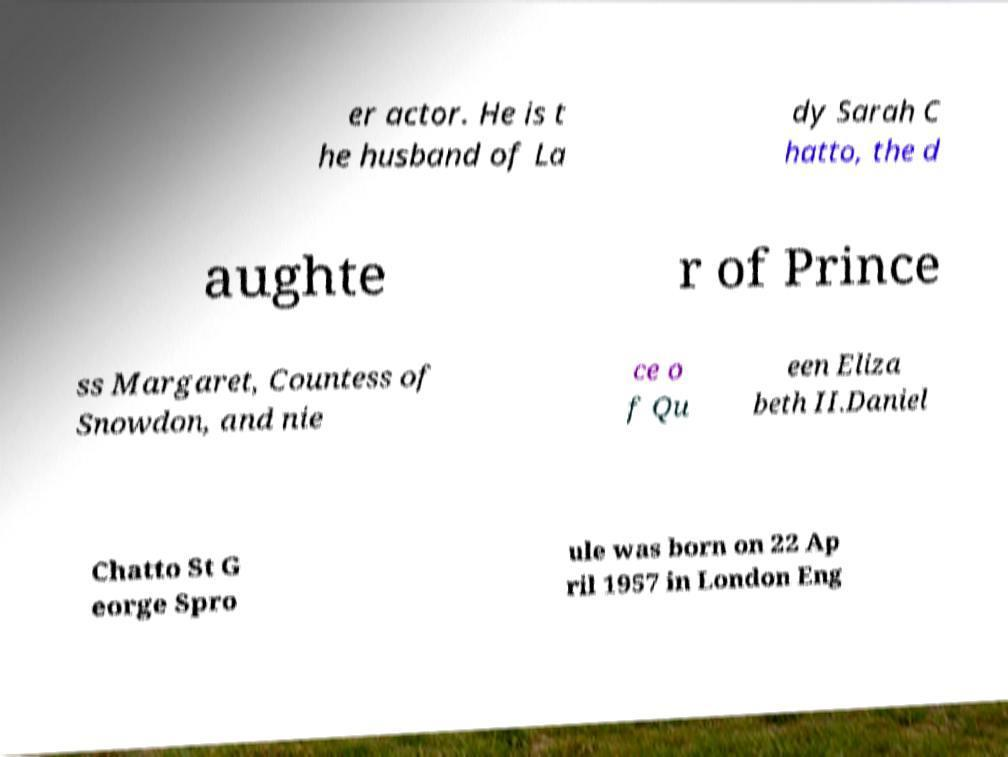Please read and relay the text visible in this image. What does it say? er actor. He is t he husband of La dy Sarah C hatto, the d aughte r of Prince ss Margaret, Countess of Snowdon, and nie ce o f Qu een Eliza beth II.Daniel Chatto St G eorge Spro ule was born on 22 Ap ril 1957 in London Eng 